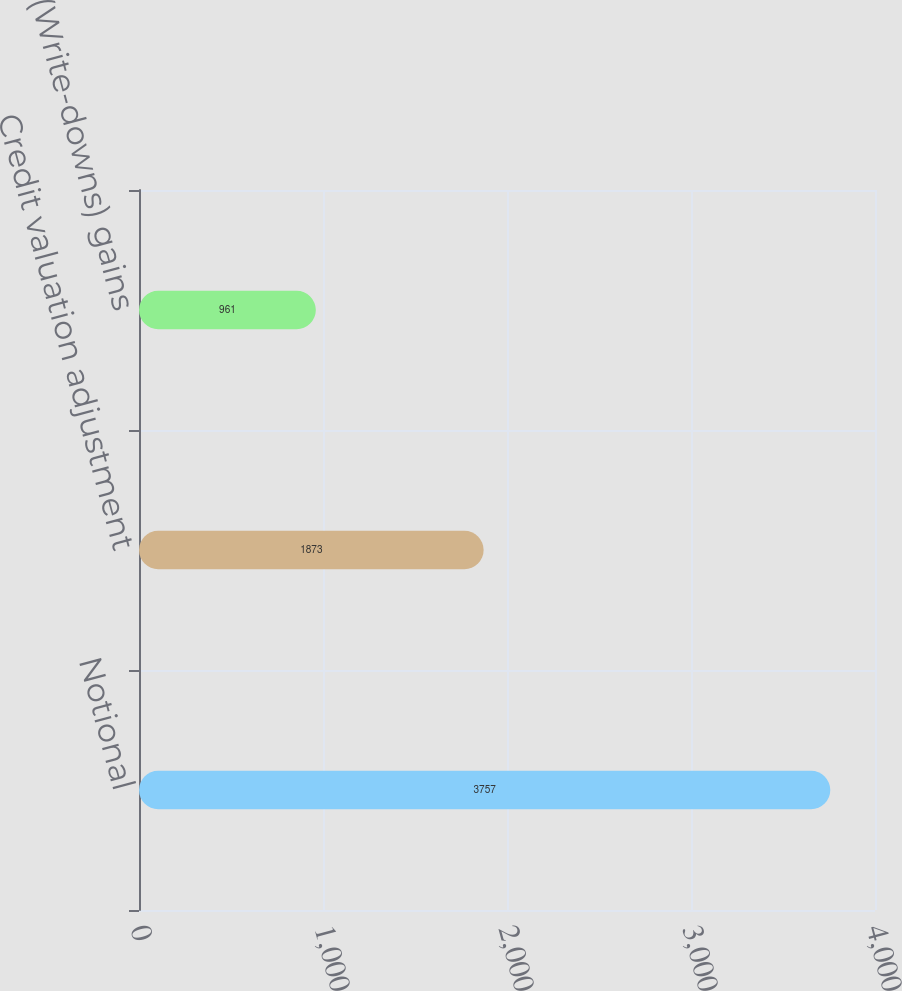Convert chart to OTSL. <chart><loc_0><loc_0><loc_500><loc_500><bar_chart><fcel>Notional<fcel>Credit valuation adjustment<fcel>(Write-downs) gains<nl><fcel>3757<fcel>1873<fcel>961<nl></chart> 